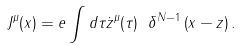<formula> <loc_0><loc_0><loc_500><loc_500>J ^ { \mu } ( x ) = e \int d \tau \dot { z } ^ { \mu } ( \tau ) \ \delta ^ { N - 1 } \left ( x - z \right ) .</formula> 